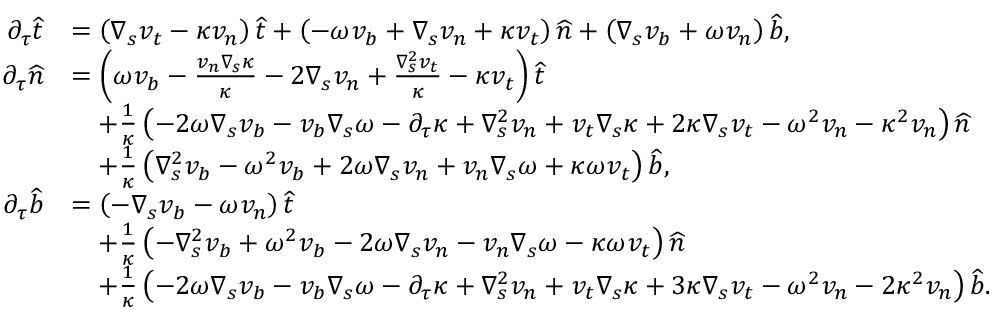<formula> <loc_0><loc_0><loc_500><loc_500>\begin{array} { r l } { \partial _ { \tau } \widehat { t } } & { = \left ( \nabla _ { s } v _ { t } - \kappa v _ { n } \right ) \widehat { t } + \left ( - \omega v _ { b } + \nabla _ { s } v _ { n } + \kappa v _ { t } \right ) \widehat { n } + \left ( \nabla _ { s } v _ { b } + \omega v _ { n } \right ) \widehat { b } , } \\ { \partial _ { \tau } \widehat { n } } & { = \left ( \omega v _ { b } - \frac { v _ { n } \nabla _ { s } \kappa } { \kappa } - 2 \nabla _ { s } v _ { n } + \frac { \nabla _ { s } ^ { 2 } v _ { t } } { \kappa } - \kappa v _ { t } \right ) \widehat { t } } \\ & { \quad + \frac { 1 } { \kappa } \left ( - { 2 \omega \nabla _ { s } v _ { b } } - { v _ { b } \nabla _ { s } \omega } - { \partial _ { \tau } \kappa } + { \nabla _ { s } ^ { 2 } v _ { n } } + { v _ { t } \nabla _ { s } \kappa } + 2 \kappa \nabla _ { s } v _ { t } - { \omega ^ { 2 } v _ { n } } - \kappa ^ { 2 } v _ { n } \right ) \widehat { n } } \\ & { \quad + \frac { 1 } { \kappa } \left ( { \nabla _ { s } ^ { 2 } v _ { b } } - { \omega ^ { 2 } v _ { b } } + { 2 \omega \nabla _ { s } v _ { n } } + { v _ { n } \nabla _ { s } \omega } + \kappa \omega v _ { t } \right ) \widehat { b } , } \\ { \partial _ { \tau } \widehat { b } } & { = \left ( - \nabla _ { s } v _ { b } - \omega v _ { n } \right ) \widehat { t } } \\ & { \quad + \frac { 1 } { \kappa } \left ( - { \nabla _ { s } ^ { 2 } v _ { b } } + { \omega ^ { 2 } v _ { b } } - { 2 \omega \nabla _ { s } v _ { n } } - { v _ { n } \nabla _ { s } \omega } - \kappa \omega v _ { t } \right ) \widehat { n } } \\ & { \quad + \frac { 1 } { \kappa } \left ( - { 2 \omega \nabla _ { s } v _ { b } } - { v _ { b } \nabla _ { s } \omega } - { \partial _ { \tau } \kappa } + { \nabla _ { s } ^ { 2 } v _ { n } } + { v _ { t } \nabla _ { s } \kappa } + 3 \kappa \nabla _ { s } v _ { t } - { \omega ^ { 2 } v _ { n } } - 2 \kappa ^ { 2 } v _ { n } \right ) \widehat { b } . } \end{array}</formula> 